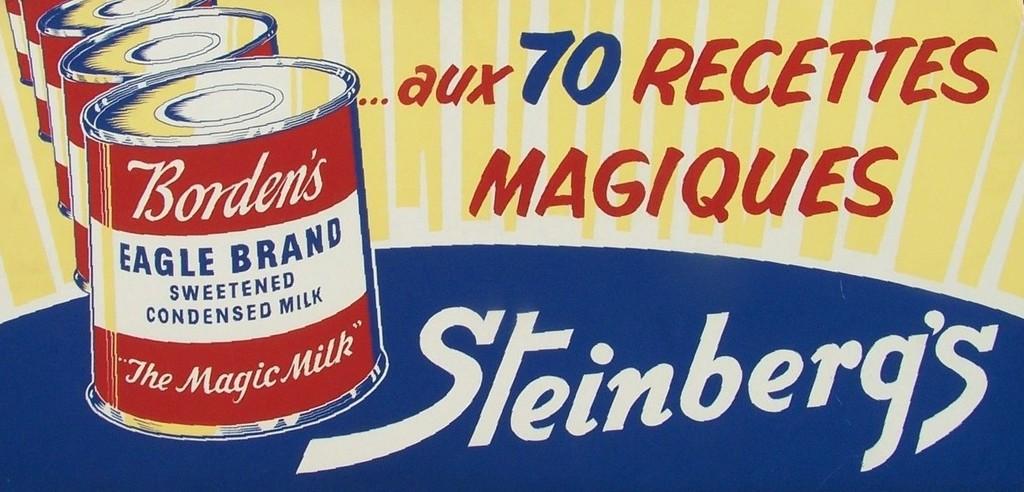Which brand is promoting this product?
Keep it short and to the point. Steinberg's. 